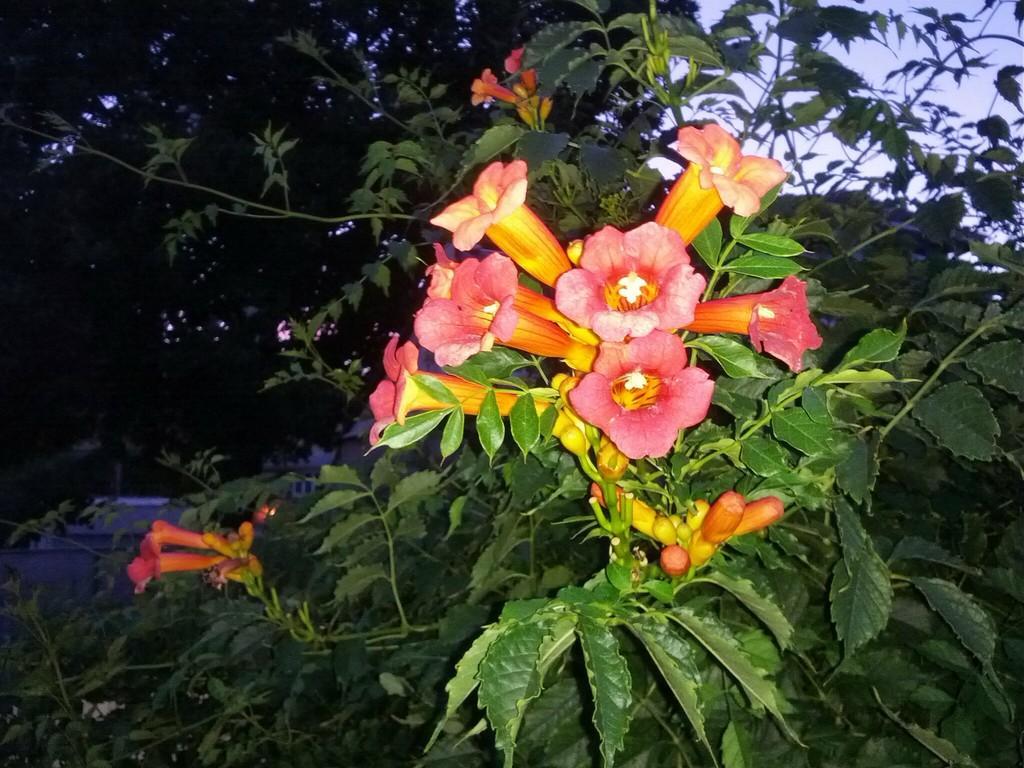Could you give a brief overview of what you see in this image? There are flowers and buds on a plant. In the back there are trees and sky. 